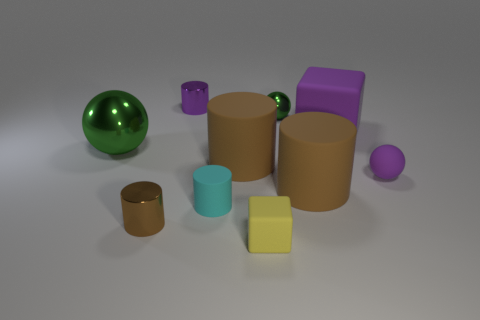There is a green thing that is to the right of the small brown thing; is there a large rubber object that is to the right of it?
Keep it short and to the point. Yes. Are there any small green balls to the left of the small yellow block?
Give a very brief answer. No. There is a big matte object in front of the small purple rubber ball; is it the same shape as the tiny green metallic thing?
Offer a terse response. No. How many small brown shiny objects are the same shape as the large green metallic object?
Your answer should be very brief. 0. Is there a tiny green block made of the same material as the purple cube?
Your answer should be compact. No. What material is the small purple thing that is on the right side of the green ball on the right side of the cyan cylinder?
Your answer should be compact. Rubber. There is a cube that is in front of the big metallic ball; how big is it?
Keep it short and to the point. Small. Do the tiny rubber cylinder and the metallic ball that is left of the small rubber cube have the same color?
Your answer should be very brief. No. Is there another tiny ball that has the same color as the rubber ball?
Keep it short and to the point. No. Does the purple cylinder have the same material as the tiny yellow cube that is in front of the small purple cylinder?
Your response must be concise. No. 